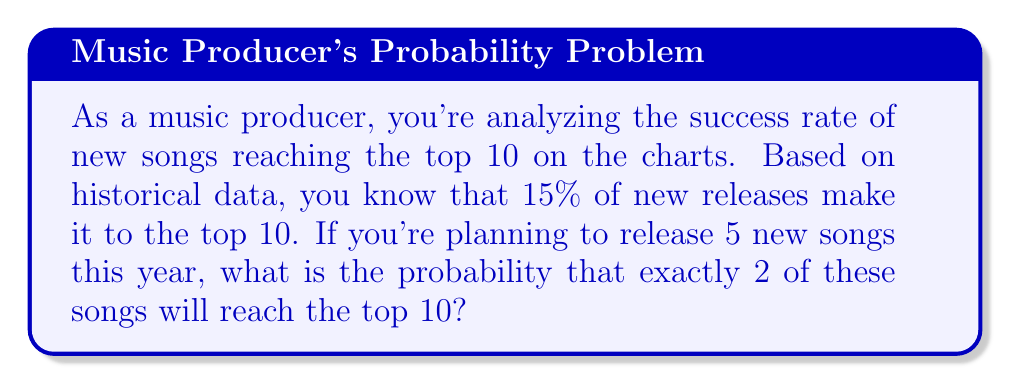Can you solve this math problem? Let's approach this step-by-step using the binomial probability distribution:

1) This scenario follows a binomial distribution because:
   - There are a fixed number of trials (5 songs)
   - Each trial has two possible outcomes (reach top 10 or not)
   - The probability of success is constant for each trial
   - The trials are independent

2) We'll use the binomial probability formula:

   $$ P(X = k) = \binom{n}{k} p^k (1-p)^{n-k} $$

   Where:
   $n$ = number of trials (5 songs)
   $k$ = number of successes (2 songs reaching top 10)
   $p$ = probability of success for each trial (15% or 0.15)

3) Let's calculate each part:

   $\binom{n}{k} = \binom{5}{2} = \frac{5!}{2!(5-2)!} = 10$

   $p^k = 0.15^2 = 0.0225$

   $(1-p)^{n-k} = (1-0.15)^{5-2} = 0.85^3 = 0.614125$

4) Now, let's put it all together:

   $$ P(X = 2) = 10 \times 0.0225 \times 0.614125 = 0.138178125 $$

5) Therefore, the probability is approximately 0.1382 or 13.82%.
Answer: 0.1382 